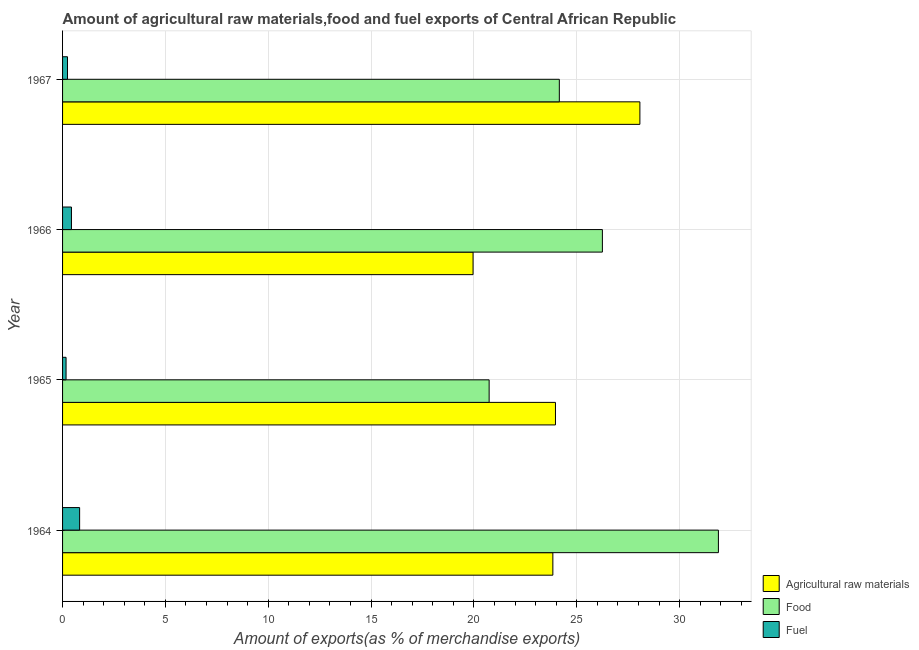Are the number of bars per tick equal to the number of legend labels?
Your answer should be very brief. Yes. How many bars are there on the 1st tick from the top?
Provide a succinct answer. 3. What is the label of the 2nd group of bars from the top?
Provide a succinct answer. 1966. What is the percentage of fuel exports in 1964?
Your answer should be very brief. 0.83. Across all years, what is the maximum percentage of food exports?
Your answer should be very brief. 31.89. Across all years, what is the minimum percentage of food exports?
Ensure brevity in your answer.  20.74. In which year was the percentage of food exports maximum?
Your answer should be compact. 1964. In which year was the percentage of fuel exports minimum?
Provide a succinct answer. 1965. What is the total percentage of fuel exports in the graph?
Offer a terse response. 1.67. What is the difference between the percentage of food exports in 1964 and that in 1965?
Ensure brevity in your answer.  11.15. What is the difference between the percentage of raw materials exports in 1964 and the percentage of food exports in 1967?
Offer a terse response. -0.31. What is the average percentage of fuel exports per year?
Provide a short and direct response. 0.42. In the year 1966, what is the difference between the percentage of raw materials exports and percentage of food exports?
Keep it short and to the point. -6.29. What is the ratio of the percentage of fuel exports in 1965 to that in 1967?
Your answer should be compact. 0.71. What is the difference between the highest and the second highest percentage of food exports?
Provide a succinct answer. 5.64. What is the difference between the highest and the lowest percentage of food exports?
Offer a very short reply. 11.15. Is the sum of the percentage of raw materials exports in 1964 and 1965 greater than the maximum percentage of food exports across all years?
Offer a very short reply. Yes. What does the 1st bar from the top in 1967 represents?
Your answer should be compact. Fuel. What does the 2nd bar from the bottom in 1965 represents?
Your answer should be very brief. Food. How many bars are there?
Ensure brevity in your answer.  12. Are all the bars in the graph horizontal?
Ensure brevity in your answer.  Yes. Does the graph contain grids?
Make the answer very short. Yes. How are the legend labels stacked?
Your answer should be very brief. Vertical. What is the title of the graph?
Ensure brevity in your answer.  Amount of agricultural raw materials,food and fuel exports of Central African Republic. Does "Ages 50+" appear as one of the legend labels in the graph?
Your response must be concise. No. What is the label or title of the X-axis?
Give a very brief answer. Amount of exports(as % of merchandise exports). What is the Amount of exports(as % of merchandise exports) in Agricultural raw materials in 1964?
Your answer should be very brief. 23.84. What is the Amount of exports(as % of merchandise exports) in Food in 1964?
Your answer should be very brief. 31.89. What is the Amount of exports(as % of merchandise exports) of Fuel in 1964?
Ensure brevity in your answer.  0.83. What is the Amount of exports(as % of merchandise exports) of Agricultural raw materials in 1965?
Your answer should be compact. 23.96. What is the Amount of exports(as % of merchandise exports) in Food in 1965?
Your response must be concise. 20.74. What is the Amount of exports(as % of merchandise exports) of Fuel in 1965?
Ensure brevity in your answer.  0.17. What is the Amount of exports(as % of merchandise exports) in Agricultural raw materials in 1966?
Ensure brevity in your answer.  19.96. What is the Amount of exports(as % of merchandise exports) in Food in 1966?
Your answer should be compact. 26.25. What is the Amount of exports(as % of merchandise exports) in Fuel in 1966?
Give a very brief answer. 0.43. What is the Amount of exports(as % of merchandise exports) in Agricultural raw materials in 1967?
Provide a short and direct response. 28.07. What is the Amount of exports(as % of merchandise exports) of Food in 1967?
Give a very brief answer. 24.15. What is the Amount of exports(as % of merchandise exports) in Fuel in 1967?
Ensure brevity in your answer.  0.24. Across all years, what is the maximum Amount of exports(as % of merchandise exports) of Agricultural raw materials?
Your answer should be compact. 28.07. Across all years, what is the maximum Amount of exports(as % of merchandise exports) in Food?
Make the answer very short. 31.89. Across all years, what is the maximum Amount of exports(as % of merchandise exports) of Fuel?
Offer a terse response. 0.83. Across all years, what is the minimum Amount of exports(as % of merchandise exports) in Agricultural raw materials?
Offer a terse response. 19.96. Across all years, what is the minimum Amount of exports(as % of merchandise exports) of Food?
Keep it short and to the point. 20.74. Across all years, what is the minimum Amount of exports(as % of merchandise exports) of Fuel?
Your response must be concise. 0.17. What is the total Amount of exports(as % of merchandise exports) in Agricultural raw materials in the graph?
Ensure brevity in your answer.  95.83. What is the total Amount of exports(as % of merchandise exports) of Food in the graph?
Provide a short and direct response. 103.03. What is the total Amount of exports(as % of merchandise exports) of Fuel in the graph?
Give a very brief answer. 1.67. What is the difference between the Amount of exports(as % of merchandise exports) of Agricultural raw materials in 1964 and that in 1965?
Provide a succinct answer. -0.13. What is the difference between the Amount of exports(as % of merchandise exports) in Food in 1964 and that in 1965?
Make the answer very short. 11.15. What is the difference between the Amount of exports(as % of merchandise exports) of Fuel in 1964 and that in 1965?
Provide a short and direct response. 0.66. What is the difference between the Amount of exports(as % of merchandise exports) in Agricultural raw materials in 1964 and that in 1966?
Give a very brief answer. 3.88. What is the difference between the Amount of exports(as % of merchandise exports) of Food in 1964 and that in 1966?
Offer a terse response. 5.64. What is the difference between the Amount of exports(as % of merchandise exports) in Fuel in 1964 and that in 1966?
Give a very brief answer. 0.4. What is the difference between the Amount of exports(as % of merchandise exports) in Agricultural raw materials in 1964 and that in 1967?
Keep it short and to the point. -4.23. What is the difference between the Amount of exports(as % of merchandise exports) of Food in 1964 and that in 1967?
Your answer should be compact. 7.73. What is the difference between the Amount of exports(as % of merchandise exports) of Fuel in 1964 and that in 1967?
Your answer should be very brief. 0.59. What is the difference between the Amount of exports(as % of merchandise exports) in Agricultural raw materials in 1965 and that in 1966?
Make the answer very short. 4.01. What is the difference between the Amount of exports(as % of merchandise exports) in Food in 1965 and that in 1966?
Provide a succinct answer. -5.51. What is the difference between the Amount of exports(as % of merchandise exports) of Fuel in 1965 and that in 1966?
Offer a terse response. -0.26. What is the difference between the Amount of exports(as % of merchandise exports) of Agricultural raw materials in 1965 and that in 1967?
Offer a terse response. -4.1. What is the difference between the Amount of exports(as % of merchandise exports) in Food in 1965 and that in 1967?
Your answer should be very brief. -3.41. What is the difference between the Amount of exports(as % of merchandise exports) of Fuel in 1965 and that in 1967?
Keep it short and to the point. -0.07. What is the difference between the Amount of exports(as % of merchandise exports) in Agricultural raw materials in 1966 and that in 1967?
Offer a terse response. -8.11. What is the difference between the Amount of exports(as % of merchandise exports) of Food in 1966 and that in 1967?
Provide a succinct answer. 2.09. What is the difference between the Amount of exports(as % of merchandise exports) in Fuel in 1966 and that in 1967?
Keep it short and to the point. 0.19. What is the difference between the Amount of exports(as % of merchandise exports) in Agricultural raw materials in 1964 and the Amount of exports(as % of merchandise exports) in Food in 1965?
Offer a very short reply. 3.1. What is the difference between the Amount of exports(as % of merchandise exports) of Agricultural raw materials in 1964 and the Amount of exports(as % of merchandise exports) of Fuel in 1965?
Offer a terse response. 23.67. What is the difference between the Amount of exports(as % of merchandise exports) of Food in 1964 and the Amount of exports(as % of merchandise exports) of Fuel in 1965?
Your answer should be very brief. 31.72. What is the difference between the Amount of exports(as % of merchandise exports) in Agricultural raw materials in 1964 and the Amount of exports(as % of merchandise exports) in Food in 1966?
Your answer should be very brief. -2.41. What is the difference between the Amount of exports(as % of merchandise exports) in Agricultural raw materials in 1964 and the Amount of exports(as % of merchandise exports) in Fuel in 1966?
Offer a terse response. 23.41. What is the difference between the Amount of exports(as % of merchandise exports) in Food in 1964 and the Amount of exports(as % of merchandise exports) in Fuel in 1966?
Your answer should be very brief. 31.45. What is the difference between the Amount of exports(as % of merchandise exports) in Agricultural raw materials in 1964 and the Amount of exports(as % of merchandise exports) in Food in 1967?
Your response must be concise. -0.31. What is the difference between the Amount of exports(as % of merchandise exports) in Agricultural raw materials in 1964 and the Amount of exports(as % of merchandise exports) in Fuel in 1967?
Your response must be concise. 23.6. What is the difference between the Amount of exports(as % of merchandise exports) of Food in 1964 and the Amount of exports(as % of merchandise exports) of Fuel in 1967?
Provide a short and direct response. 31.65. What is the difference between the Amount of exports(as % of merchandise exports) of Agricultural raw materials in 1965 and the Amount of exports(as % of merchandise exports) of Food in 1966?
Provide a succinct answer. -2.28. What is the difference between the Amount of exports(as % of merchandise exports) in Agricultural raw materials in 1965 and the Amount of exports(as % of merchandise exports) in Fuel in 1966?
Offer a very short reply. 23.53. What is the difference between the Amount of exports(as % of merchandise exports) of Food in 1965 and the Amount of exports(as % of merchandise exports) of Fuel in 1966?
Offer a very short reply. 20.31. What is the difference between the Amount of exports(as % of merchandise exports) of Agricultural raw materials in 1965 and the Amount of exports(as % of merchandise exports) of Food in 1967?
Your response must be concise. -0.19. What is the difference between the Amount of exports(as % of merchandise exports) of Agricultural raw materials in 1965 and the Amount of exports(as % of merchandise exports) of Fuel in 1967?
Offer a very short reply. 23.73. What is the difference between the Amount of exports(as % of merchandise exports) of Food in 1965 and the Amount of exports(as % of merchandise exports) of Fuel in 1967?
Offer a terse response. 20.5. What is the difference between the Amount of exports(as % of merchandise exports) in Agricultural raw materials in 1966 and the Amount of exports(as % of merchandise exports) in Food in 1967?
Make the answer very short. -4.19. What is the difference between the Amount of exports(as % of merchandise exports) in Agricultural raw materials in 1966 and the Amount of exports(as % of merchandise exports) in Fuel in 1967?
Your answer should be compact. 19.72. What is the difference between the Amount of exports(as % of merchandise exports) in Food in 1966 and the Amount of exports(as % of merchandise exports) in Fuel in 1967?
Your response must be concise. 26.01. What is the average Amount of exports(as % of merchandise exports) of Agricultural raw materials per year?
Your answer should be compact. 23.96. What is the average Amount of exports(as % of merchandise exports) in Food per year?
Your answer should be very brief. 25.76. What is the average Amount of exports(as % of merchandise exports) in Fuel per year?
Ensure brevity in your answer.  0.42. In the year 1964, what is the difference between the Amount of exports(as % of merchandise exports) in Agricultural raw materials and Amount of exports(as % of merchandise exports) in Food?
Keep it short and to the point. -8.05. In the year 1964, what is the difference between the Amount of exports(as % of merchandise exports) of Agricultural raw materials and Amount of exports(as % of merchandise exports) of Fuel?
Offer a terse response. 23.01. In the year 1964, what is the difference between the Amount of exports(as % of merchandise exports) in Food and Amount of exports(as % of merchandise exports) in Fuel?
Your answer should be compact. 31.06. In the year 1965, what is the difference between the Amount of exports(as % of merchandise exports) in Agricultural raw materials and Amount of exports(as % of merchandise exports) in Food?
Ensure brevity in your answer.  3.23. In the year 1965, what is the difference between the Amount of exports(as % of merchandise exports) in Agricultural raw materials and Amount of exports(as % of merchandise exports) in Fuel?
Make the answer very short. 23.8. In the year 1965, what is the difference between the Amount of exports(as % of merchandise exports) in Food and Amount of exports(as % of merchandise exports) in Fuel?
Provide a short and direct response. 20.57. In the year 1966, what is the difference between the Amount of exports(as % of merchandise exports) of Agricultural raw materials and Amount of exports(as % of merchandise exports) of Food?
Your response must be concise. -6.29. In the year 1966, what is the difference between the Amount of exports(as % of merchandise exports) of Agricultural raw materials and Amount of exports(as % of merchandise exports) of Fuel?
Provide a short and direct response. 19.53. In the year 1966, what is the difference between the Amount of exports(as % of merchandise exports) of Food and Amount of exports(as % of merchandise exports) of Fuel?
Offer a very short reply. 25.81. In the year 1967, what is the difference between the Amount of exports(as % of merchandise exports) in Agricultural raw materials and Amount of exports(as % of merchandise exports) in Food?
Provide a succinct answer. 3.92. In the year 1967, what is the difference between the Amount of exports(as % of merchandise exports) in Agricultural raw materials and Amount of exports(as % of merchandise exports) in Fuel?
Give a very brief answer. 27.83. In the year 1967, what is the difference between the Amount of exports(as % of merchandise exports) in Food and Amount of exports(as % of merchandise exports) in Fuel?
Your answer should be compact. 23.91. What is the ratio of the Amount of exports(as % of merchandise exports) of Agricultural raw materials in 1964 to that in 1965?
Ensure brevity in your answer.  0.99. What is the ratio of the Amount of exports(as % of merchandise exports) of Food in 1964 to that in 1965?
Your answer should be compact. 1.54. What is the ratio of the Amount of exports(as % of merchandise exports) of Fuel in 1964 to that in 1965?
Provide a succinct answer. 4.88. What is the ratio of the Amount of exports(as % of merchandise exports) of Agricultural raw materials in 1964 to that in 1966?
Give a very brief answer. 1.19. What is the ratio of the Amount of exports(as % of merchandise exports) in Food in 1964 to that in 1966?
Give a very brief answer. 1.21. What is the ratio of the Amount of exports(as % of merchandise exports) of Fuel in 1964 to that in 1966?
Ensure brevity in your answer.  1.92. What is the ratio of the Amount of exports(as % of merchandise exports) of Agricultural raw materials in 1964 to that in 1967?
Your answer should be very brief. 0.85. What is the ratio of the Amount of exports(as % of merchandise exports) in Food in 1964 to that in 1967?
Your response must be concise. 1.32. What is the ratio of the Amount of exports(as % of merchandise exports) in Fuel in 1964 to that in 1967?
Ensure brevity in your answer.  3.46. What is the ratio of the Amount of exports(as % of merchandise exports) of Agricultural raw materials in 1965 to that in 1966?
Your answer should be very brief. 1.2. What is the ratio of the Amount of exports(as % of merchandise exports) of Food in 1965 to that in 1966?
Make the answer very short. 0.79. What is the ratio of the Amount of exports(as % of merchandise exports) in Fuel in 1965 to that in 1966?
Provide a succinct answer. 0.39. What is the ratio of the Amount of exports(as % of merchandise exports) in Agricultural raw materials in 1965 to that in 1967?
Offer a very short reply. 0.85. What is the ratio of the Amount of exports(as % of merchandise exports) in Food in 1965 to that in 1967?
Provide a succinct answer. 0.86. What is the ratio of the Amount of exports(as % of merchandise exports) in Fuel in 1965 to that in 1967?
Your answer should be very brief. 0.71. What is the ratio of the Amount of exports(as % of merchandise exports) of Agricultural raw materials in 1966 to that in 1967?
Your answer should be very brief. 0.71. What is the ratio of the Amount of exports(as % of merchandise exports) of Food in 1966 to that in 1967?
Keep it short and to the point. 1.09. What is the ratio of the Amount of exports(as % of merchandise exports) in Fuel in 1966 to that in 1967?
Offer a terse response. 1.8. What is the difference between the highest and the second highest Amount of exports(as % of merchandise exports) in Agricultural raw materials?
Your response must be concise. 4.1. What is the difference between the highest and the second highest Amount of exports(as % of merchandise exports) of Food?
Provide a succinct answer. 5.64. What is the difference between the highest and the second highest Amount of exports(as % of merchandise exports) of Fuel?
Ensure brevity in your answer.  0.4. What is the difference between the highest and the lowest Amount of exports(as % of merchandise exports) of Agricultural raw materials?
Your answer should be compact. 8.11. What is the difference between the highest and the lowest Amount of exports(as % of merchandise exports) in Food?
Your answer should be compact. 11.15. What is the difference between the highest and the lowest Amount of exports(as % of merchandise exports) of Fuel?
Your response must be concise. 0.66. 